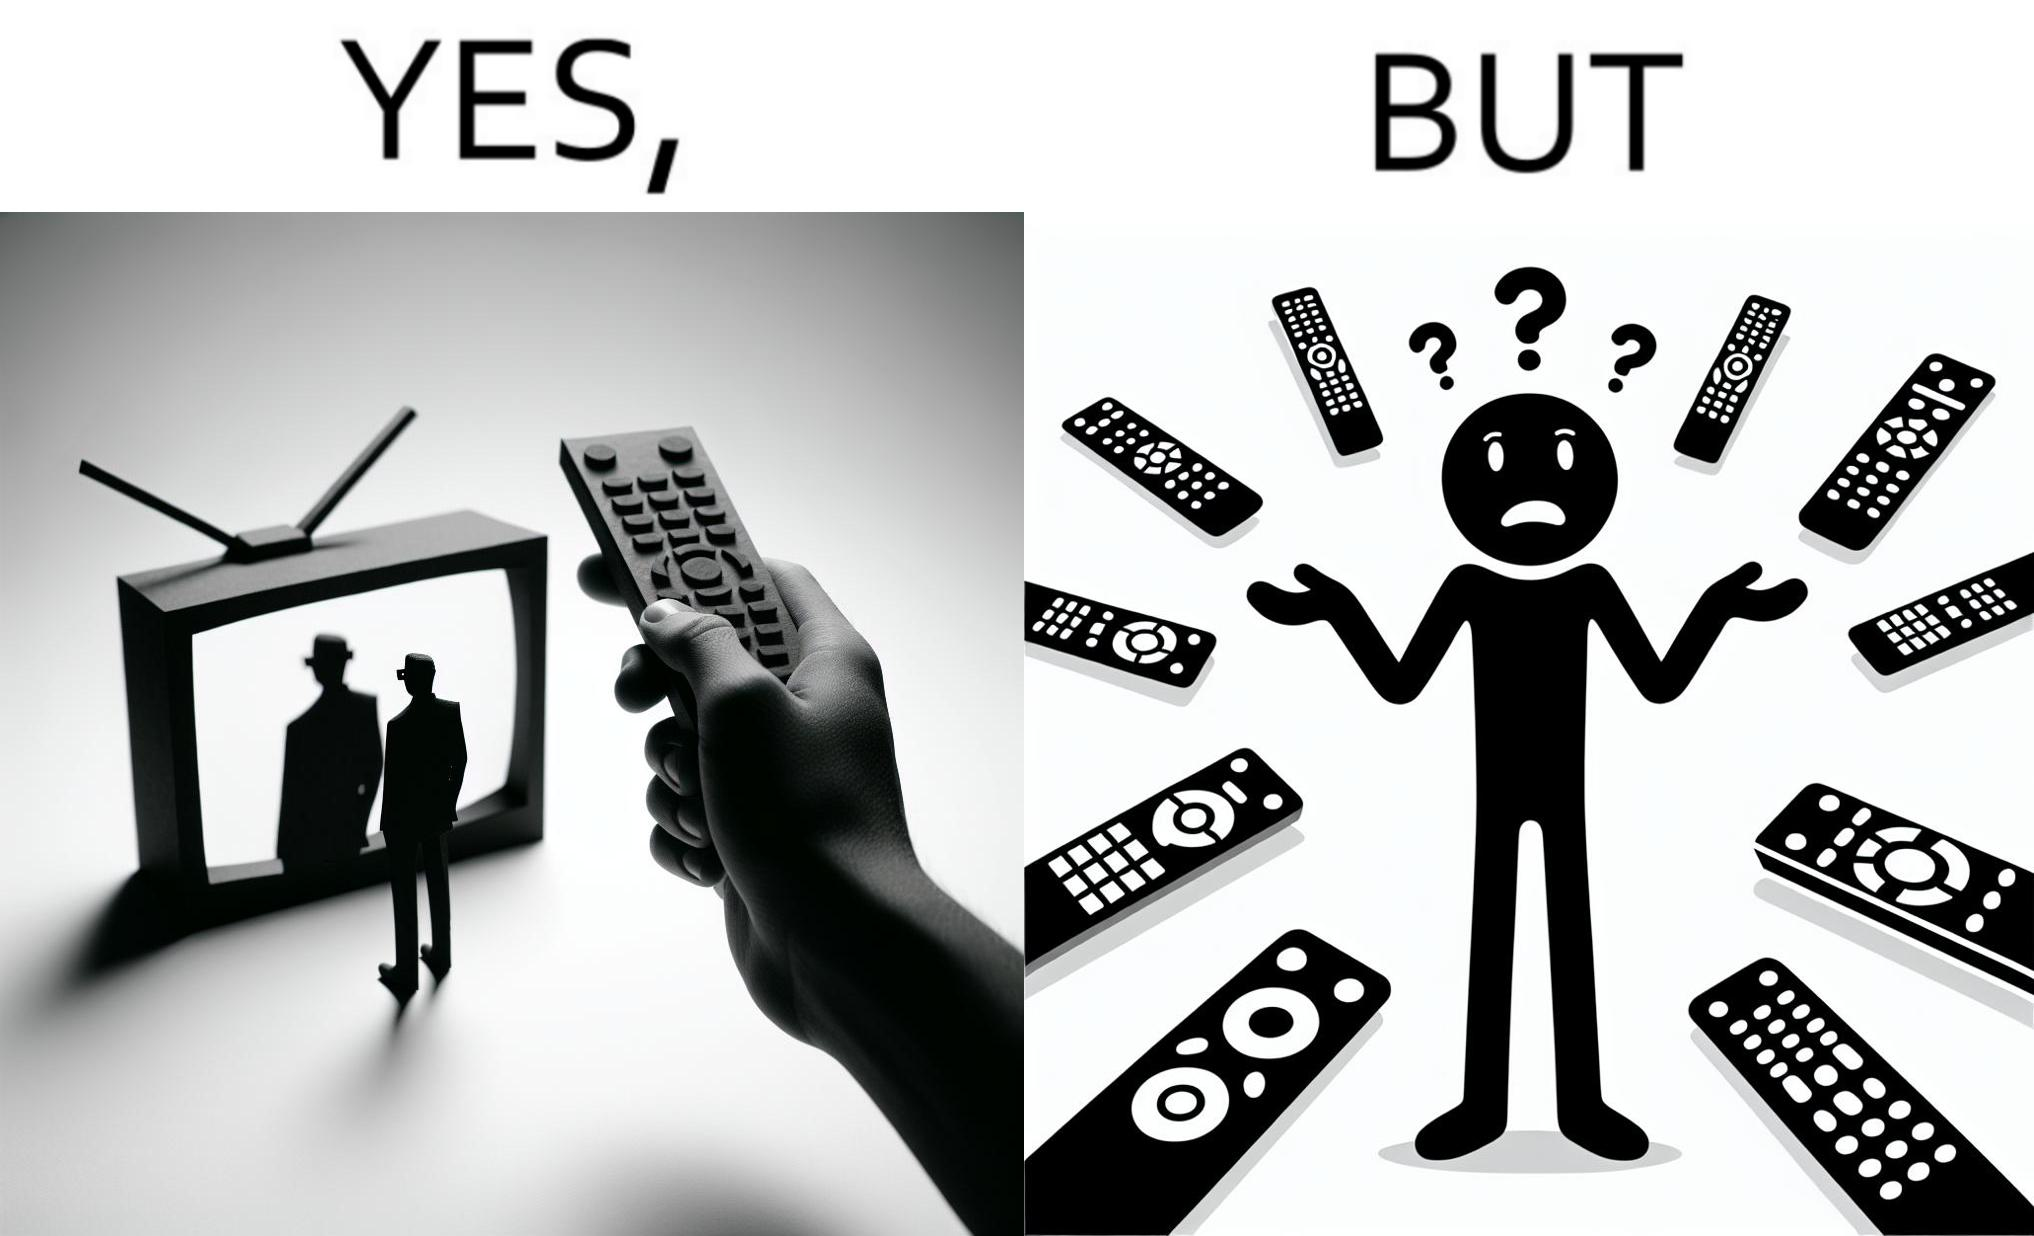What is shown in this image? The images are funny since they show how even though TV remotes are supposed to make operating TVs easier, having multiple similar looking remotes  for everything only makes it more difficult for the user to use the right one 